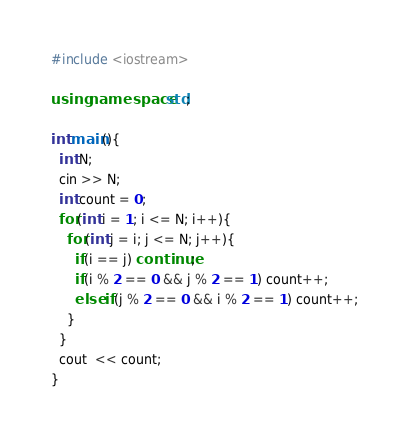Convert code to text. <code><loc_0><loc_0><loc_500><loc_500><_C++_>#include <iostream>

using namespace std;

int main(){
  int N;
  cin >> N;
  int count = 0;
  for(int i = 1; i <= N; i++){
    for(int j = i; j <= N; j++){
      if(i == j) continue;
      if(i % 2 == 0 && j % 2 == 1) count++;
      else if(j % 2 == 0 && i % 2 == 1) count++;
    }
  }
  cout  << count;
}
</code> 